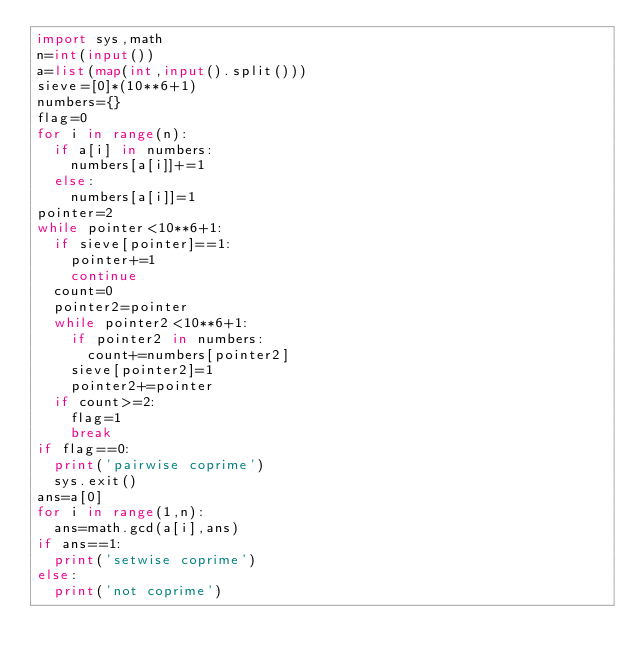<code> <loc_0><loc_0><loc_500><loc_500><_Python_>import sys,math
n=int(input())
a=list(map(int,input().split()))
sieve=[0]*(10**6+1)
numbers={}
flag=0
for i in range(n):
  if a[i] in numbers:
    numbers[a[i]]+=1
  else:
    numbers[a[i]]=1
pointer=2
while pointer<10**6+1:
  if sieve[pointer]==1:
    pointer+=1
    continue
  count=0
  pointer2=pointer
  while pointer2<10**6+1:
    if pointer2 in numbers:
      count+=numbers[pointer2]
    sieve[pointer2]=1
    pointer2+=pointer
  if count>=2:
    flag=1
    break
if flag==0:
  print('pairwise coprime')
  sys.exit()
ans=a[0]
for i in range(1,n):
  ans=math.gcd(a[i],ans)
if ans==1:
  print('setwise coprime')
else:
  print('not coprime')</code> 